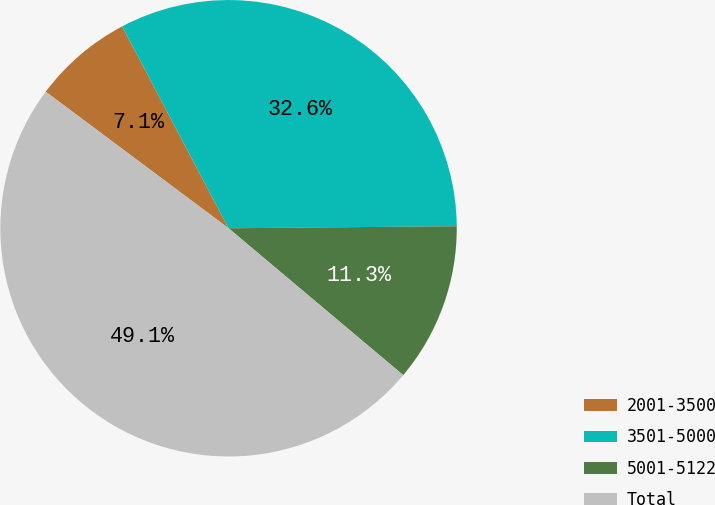<chart> <loc_0><loc_0><loc_500><loc_500><pie_chart><fcel>2001-3500<fcel>3501-5000<fcel>5001-5122<fcel>Total<nl><fcel>7.07%<fcel>32.58%<fcel>11.27%<fcel>49.08%<nl></chart> 